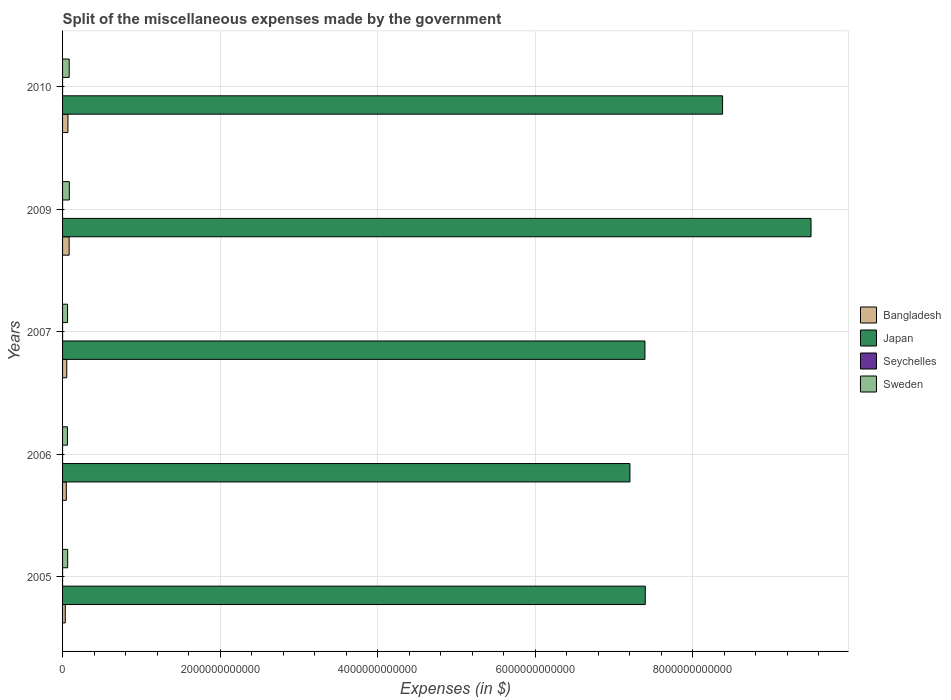How many groups of bars are there?
Offer a terse response. 5. Are the number of bars per tick equal to the number of legend labels?
Keep it short and to the point. Yes. Are the number of bars on each tick of the Y-axis equal?
Provide a succinct answer. Yes. How many bars are there on the 5th tick from the top?
Give a very brief answer. 4. What is the miscellaneous expenses made by the government in Sweden in 2006?
Your response must be concise. 6.17e+1. Across all years, what is the maximum miscellaneous expenses made by the government in Bangladesh?
Keep it short and to the point. 8.35e+1. Across all years, what is the minimum miscellaneous expenses made by the government in Sweden?
Make the answer very short. 6.17e+1. In which year was the miscellaneous expenses made by the government in Japan maximum?
Keep it short and to the point. 2009. In which year was the miscellaneous expenses made by the government in Seychelles minimum?
Ensure brevity in your answer.  2006. What is the total miscellaneous expenses made by the government in Bangladesh in the graph?
Your answer should be compact. 2.87e+11. What is the difference between the miscellaneous expenses made by the government in Bangladesh in 2007 and that in 2009?
Keep it short and to the point. -3.04e+1. What is the difference between the miscellaneous expenses made by the government in Seychelles in 2005 and the miscellaneous expenses made by the government in Bangladesh in 2007?
Your answer should be compact. -5.31e+1. What is the average miscellaneous expenses made by the government in Japan per year?
Offer a very short reply. 7.97e+12. In the year 2007, what is the difference between the miscellaneous expenses made by the government in Japan and miscellaneous expenses made by the government in Seychelles?
Your answer should be compact. 7.39e+12. What is the ratio of the miscellaneous expenses made by the government in Seychelles in 2005 to that in 2006?
Provide a succinct answer. 15.81. Is the miscellaneous expenses made by the government in Sweden in 2006 less than that in 2009?
Offer a terse response. Yes. What is the difference between the highest and the second highest miscellaneous expenses made by the government in Sweden?
Ensure brevity in your answer.  1.77e+09. What is the difference between the highest and the lowest miscellaneous expenses made by the government in Bangladesh?
Provide a short and direct response. 4.92e+1. In how many years, is the miscellaneous expenses made by the government in Sweden greater than the average miscellaneous expenses made by the government in Sweden taken over all years?
Provide a short and direct response. 2. Is it the case that in every year, the sum of the miscellaneous expenses made by the government in Japan and miscellaneous expenses made by the government in Seychelles is greater than the sum of miscellaneous expenses made by the government in Bangladesh and miscellaneous expenses made by the government in Sweden?
Ensure brevity in your answer.  Yes. What does the 2nd bar from the top in 2009 represents?
Your response must be concise. Seychelles. What does the 4th bar from the bottom in 2009 represents?
Your response must be concise. Sweden. Is it the case that in every year, the sum of the miscellaneous expenses made by the government in Bangladesh and miscellaneous expenses made by the government in Japan is greater than the miscellaneous expenses made by the government in Sweden?
Your response must be concise. Yes. How many bars are there?
Your response must be concise. 20. Are all the bars in the graph horizontal?
Your response must be concise. Yes. How many years are there in the graph?
Provide a short and direct response. 5. What is the difference between two consecutive major ticks on the X-axis?
Your answer should be compact. 2.00e+12. Does the graph contain any zero values?
Ensure brevity in your answer.  No. Where does the legend appear in the graph?
Provide a succinct answer. Center right. How many legend labels are there?
Keep it short and to the point. 4. How are the legend labels stacked?
Offer a very short reply. Vertical. What is the title of the graph?
Offer a terse response. Split of the miscellaneous expenses made by the government. Does "Armenia" appear as one of the legend labels in the graph?
Offer a very short reply. No. What is the label or title of the X-axis?
Give a very brief answer. Expenses (in $). What is the Expenses (in $) in Bangladesh in 2005?
Your answer should be compact. 3.43e+1. What is the Expenses (in $) of Japan in 2005?
Ensure brevity in your answer.  7.40e+12. What is the Expenses (in $) of Seychelles in 2005?
Provide a short and direct response. 1.26e+07. What is the Expenses (in $) of Sweden in 2005?
Give a very brief answer. 6.48e+1. What is the Expenses (in $) in Bangladesh in 2006?
Offer a very short reply. 4.73e+1. What is the Expenses (in $) of Japan in 2006?
Offer a terse response. 7.20e+12. What is the Expenses (in $) in Seychelles in 2006?
Provide a succinct answer. 8.00e+05. What is the Expenses (in $) of Sweden in 2006?
Your answer should be compact. 6.17e+1. What is the Expenses (in $) in Bangladesh in 2007?
Offer a very short reply. 5.31e+1. What is the Expenses (in $) in Japan in 2007?
Provide a succinct answer. 7.39e+12. What is the Expenses (in $) of Seychelles in 2007?
Your response must be concise. 7.22e+06. What is the Expenses (in $) in Sweden in 2007?
Keep it short and to the point. 6.32e+1. What is the Expenses (in $) of Bangladesh in 2009?
Keep it short and to the point. 8.35e+1. What is the Expenses (in $) of Japan in 2009?
Offer a terse response. 9.50e+12. What is the Expenses (in $) in Seychelles in 2009?
Give a very brief answer. 2.10e+06. What is the Expenses (in $) in Sweden in 2009?
Your answer should be compact. 8.61e+1. What is the Expenses (in $) of Bangladesh in 2010?
Give a very brief answer. 6.82e+1. What is the Expenses (in $) in Japan in 2010?
Provide a short and direct response. 8.38e+12. What is the Expenses (in $) of Seychelles in 2010?
Your response must be concise. 2.02e+06. What is the Expenses (in $) in Sweden in 2010?
Make the answer very short. 8.43e+1. Across all years, what is the maximum Expenses (in $) of Bangladesh?
Your answer should be compact. 8.35e+1. Across all years, what is the maximum Expenses (in $) of Japan?
Your response must be concise. 9.50e+12. Across all years, what is the maximum Expenses (in $) of Seychelles?
Your answer should be compact. 1.26e+07. Across all years, what is the maximum Expenses (in $) in Sweden?
Provide a succinct answer. 8.61e+1. Across all years, what is the minimum Expenses (in $) in Bangladesh?
Your answer should be compact. 3.43e+1. Across all years, what is the minimum Expenses (in $) of Japan?
Give a very brief answer. 7.20e+12. Across all years, what is the minimum Expenses (in $) of Sweden?
Your response must be concise. 6.17e+1. What is the total Expenses (in $) in Bangladesh in the graph?
Provide a succinct answer. 2.87e+11. What is the total Expenses (in $) in Japan in the graph?
Ensure brevity in your answer.  3.99e+13. What is the total Expenses (in $) in Seychelles in the graph?
Provide a succinct answer. 2.48e+07. What is the total Expenses (in $) in Sweden in the graph?
Ensure brevity in your answer.  3.60e+11. What is the difference between the Expenses (in $) of Bangladesh in 2005 and that in 2006?
Your response must be concise. -1.30e+1. What is the difference between the Expenses (in $) in Japan in 2005 and that in 2006?
Ensure brevity in your answer.  1.95e+11. What is the difference between the Expenses (in $) of Seychelles in 2005 and that in 2006?
Give a very brief answer. 1.18e+07. What is the difference between the Expenses (in $) of Sweden in 2005 and that in 2006?
Give a very brief answer. 3.06e+09. What is the difference between the Expenses (in $) of Bangladesh in 2005 and that in 2007?
Keep it short and to the point. -1.88e+1. What is the difference between the Expenses (in $) of Japan in 2005 and that in 2007?
Provide a succinct answer. 4.50e+09. What is the difference between the Expenses (in $) in Seychelles in 2005 and that in 2007?
Provide a short and direct response. 5.43e+06. What is the difference between the Expenses (in $) of Sweden in 2005 and that in 2007?
Offer a terse response. 1.60e+09. What is the difference between the Expenses (in $) in Bangladesh in 2005 and that in 2009?
Keep it short and to the point. -4.92e+1. What is the difference between the Expenses (in $) in Japan in 2005 and that in 2009?
Ensure brevity in your answer.  -2.10e+12. What is the difference between the Expenses (in $) in Seychelles in 2005 and that in 2009?
Keep it short and to the point. 1.06e+07. What is the difference between the Expenses (in $) of Sweden in 2005 and that in 2009?
Ensure brevity in your answer.  -2.13e+1. What is the difference between the Expenses (in $) of Bangladesh in 2005 and that in 2010?
Your answer should be compact. -3.39e+1. What is the difference between the Expenses (in $) of Japan in 2005 and that in 2010?
Your response must be concise. -9.81e+11. What is the difference between the Expenses (in $) of Seychelles in 2005 and that in 2010?
Make the answer very short. 1.06e+07. What is the difference between the Expenses (in $) of Sweden in 2005 and that in 2010?
Make the answer very short. -1.95e+1. What is the difference between the Expenses (in $) in Bangladesh in 2006 and that in 2007?
Provide a succinct answer. -5.81e+09. What is the difference between the Expenses (in $) in Japan in 2006 and that in 2007?
Offer a very short reply. -1.90e+11. What is the difference between the Expenses (in $) in Seychelles in 2006 and that in 2007?
Ensure brevity in your answer.  -6.42e+06. What is the difference between the Expenses (in $) in Sweden in 2006 and that in 2007?
Offer a very short reply. -1.47e+09. What is the difference between the Expenses (in $) of Bangladesh in 2006 and that in 2009?
Offer a terse response. -3.62e+1. What is the difference between the Expenses (in $) of Japan in 2006 and that in 2009?
Your answer should be compact. -2.30e+12. What is the difference between the Expenses (in $) of Seychelles in 2006 and that in 2009?
Give a very brief answer. -1.30e+06. What is the difference between the Expenses (in $) of Sweden in 2006 and that in 2009?
Offer a very short reply. -2.43e+1. What is the difference between the Expenses (in $) in Bangladesh in 2006 and that in 2010?
Offer a terse response. -2.09e+1. What is the difference between the Expenses (in $) in Japan in 2006 and that in 2010?
Offer a very short reply. -1.18e+12. What is the difference between the Expenses (in $) in Seychelles in 2006 and that in 2010?
Keep it short and to the point. -1.22e+06. What is the difference between the Expenses (in $) of Sweden in 2006 and that in 2010?
Make the answer very short. -2.26e+1. What is the difference between the Expenses (in $) in Bangladesh in 2007 and that in 2009?
Provide a succinct answer. -3.04e+1. What is the difference between the Expenses (in $) in Japan in 2007 and that in 2009?
Your answer should be very brief. -2.11e+12. What is the difference between the Expenses (in $) in Seychelles in 2007 and that in 2009?
Offer a terse response. 5.12e+06. What is the difference between the Expenses (in $) of Sweden in 2007 and that in 2009?
Offer a terse response. -2.29e+1. What is the difference between the Expenses (in $) in Bangladesh in 2007 and that in 2010?
Offer a terse response. -1.51e+1. What is the difference between the Expenses (in $) in Japan in 2007 and that in 2010?
Provide a short and direct response. -9.86e+11. What is the difference between the Expenses (in $) in Seychelles in 2007 and that in 2010?
Offer a terse response. 5.20e+06. What is the difference between the Expenses (in $) in Sweden in 2007 and that in 2010?
Keep it short and to the point. -2.11e+1. What is the difference between the Expenses (in $) in Bangladesh in 2009 and that in 2010?
Make the answer very short. 1.53e+1. What is the difference between the Expenses (in $) of Japan in 2009 and that in 2010?
Offer a terse response. 1.12e+12. What is the difference between the Expenses (in $) in Seychelles in 2009 and that in 2010?
Offer a terse response. 7.75e+04. What is the difference between the Expenses (in $) of Sweden in 2009 and that in 2010?
Offer a terse response. 1.77e+09. What is the difference between the Expenses (in $) of Bangladesh in 2005 and the Expenses (in $) of Japan in 2006?
Your answer should be compact. -7.17e+12. What is the difference between the Expenses (in $) in Bangladesh in 2005 and the Expenses (in $) in Seychelles in 2006?
Give a very brief answer. 3.43e+1. What is the difference between the Expenses (in $) of Bangladesh in 2005 and the Expenses (in $) of Sweden in 2006?
Offer a terse response. -2.74e+1. What is the difference between the Expenses (in $) of Japan in 2005 and the Expenses (in $) of Seychelles in 2006?
Your answer should be very brief. 7.40e+12. What is the difference between the Expenses (in $) of Japan in 2005 and the Expenses (in $) of Sweden in 2006?
Your answer should be compact. 7.33e+12. What is the difference between the Expenses (in $) of Seychelles in 2005 and the Expenses (in $) of Sweden in 2006?
Provide a short and direct response. -6.17e+1. What is the difference between the Expenses (in $) of Bangladesh in 2005 and the Expenses (in $) of Japan in 2007?
Provide a short and direct response. -7.36e+12. What is the difference between the Expenses (in $) of Bangladesh in 2005 and the Expenses (in $) of Seychelles in 2007?
Provide a succinct answer. 3.43e+1. What is the difference between the Expenses (in $) of Bangladesh in 2005 and the Expenses (in $) of Sweden in 2007?
Offer a terse response. -2.89e+1. What is the difference between the Expenses (in $) in Japan in 2005 and the Expenses (in $) in Seychelles in 2007?
Make the answer very short. 7.40e+12. What is the difference between the Expenses (in $) in Japan in 2005 and the Expenses (in $) in Sweden in 2007?
Provide a short and direct response. 7.33e+12. What is the difference between the Expenses (in $) of Seychelles in 2005 and the Expenses (in $) of Sweden in 2007?
Your answer should be very brief. -6.32e+1. What is the difference between the Expenses (in $) in Bangladesh in 2005 and the Expenses (in $) in Japan in 2009?
Offer a very short reply. -9.47e+12. What is the difference between the Expenses (in $) of Bangladesh in 2005 and the Expenses (in $) of Seychelles in 2009?
Offer a very short reply. 3.43e+1. What is the difference between the Expenses (in $) in Bangladesh in 2005 and the Expenses (in $) in Sweden in 2009?
Offer a terse response. -5.17e+1. What is the difference between the Expenses (in $) of Japan in 2005 and the Expenses (in $) of Seychelles in 2009?
Provide a short and direct response. 7.40e+12. What is the difference between the Expenses (in $) in Japan in 2005 and the Expenses (in $) in Sweden in 2009?
Ensure brevity in your answer.  7.31e+12. What is the difference between the Expenses (in $) of Seychelles in 2005 and the Expenses (in $) of Sweden in 2009?
Provide a short and direct response. -8.61e+1. What is the difference between the Expenses (in $) of Bangladesh in 2005 and the Expenses (in $) of Japan in 2010?
Provide a succinct answer. -8.34e+12. What is the difference between the Expenses (in $) of Bangladesh in 2005 and the Expenses (in $) of Seychelles in 2010?
Your response must be concise. 3.43e+1. What is the difference between the Expenses (in $) of Bangladesh in 2005 and the Expenses (in $) of Sweden in 2010?
Your response must be concise. -5.00e+1. What is the difference between the Expenses (in $) of Japan in 2005 and the Expenses (in $) of Seychelles in 2010?
Give a very brief answer. 7.40e+12. What is the difference between the Expenses (in $) of Japan in 2005 and the Expenses (in $) of Sweden in 2010?
Your answer should be compact. 7.31e+12. What is the difference between the Expenses (in $) in Seychelles in 2005 and the Expenses (in $) in Sweden in 2010?
Provide a succinct answer. -8.43e+1. What is the difference between the Expenses (in $) in Bangladesh in 2006 and the Expenses (in $) in Japan in 2007?
Your answer should be very brief. -7.34e+12. What is the difference between the Expenses (in $) in Bangladesh in 2006 and the Expenses (in $) in Seychelles in 2007?
Make the answer very short. 4.73e+1. What is the difference between the Expenses (in $) of Bangladesh in 2006 and the Expenses (in $) of Sweden in 2007?
Keep it short and to the point. -1.59e+1. What is the difference between the Expenses (in $) of Japan in 2006 and the Expenses (in $) of Seychelles in 2007?
Provide a succinct answer. 7.20e+12. What is the difference between the Expenses (in $) in Japan in 2006 and the Expenses (in $) in Sweden in 2007?
Your answer should be very brief. 7.14e+12. What is the difference between the Expenses (in $) in Seychelles in 2006 and the Expenses (in $) in Sweden in 2007?
Make the answer very short. -6.32e+1. What is the difference between the Expenses (in $) of Bangladesh in 2006 and the Expenses (in $) of Japan in 2009?
Give a very brief answer. -9.45e+12. What is the difference between the Expenses (in $) in Bangladesh in 2006 and the Expenses (in $) in Seychelles in 2009?
Make the answer very short. 4.73e+1. What is the difference between the Expenses (in $) in Bangladesh in 2006 and the Expenses (in $) in Sweden in 2009?
Ensure brevity in your answer.  -3.87e+1. What is the difference between the Expenses (in $) of Japan in 2006 and the Expenses (in $) of Seychelles in 2009?
Offer a very short reply. 7.20e+12. What is the difference between the Expenses (in $) of Japan in 2006 and the Expenses (in $) of Sweden in 2009?
Make the answer very short. 7.12e+12. What is the difference between the Expenses (in $) in Seychelles in 2006 and the Expenses (in $) in Sweden in 2009?
Offer a terse response. -8.61e+1. What is the difference between the Expenses (in $) in Bangladesh in 2006 and the Expenses (in $) in Japan in 2010?
Offer a very short reply. -8.33e+12. What is the difference between the Expenses (in $) in Bangladesh in 2006 and the Expenses (in $) in Seychelles in 2010?
Provide a succinct answer. 4.73e+1. What is the difference between the Expenses (in $) of Bangladesh in 2006 and the Expenses (in $) of Sweden in 2010?
Keep it short and to the point. -3.70e+1. What is the difference between the Expenses (in $) of Japan in 2006 and the Expenses (in $) of Seychelles in 2010?
Provide a succinct answer. 7.20e+12. What is the difference between the Expenses (in $) of Japan in 2006 and the Expenses (in $) of Sweden in 2010?
Offer a terse response. 7.12e+12. What is the difference between the Expenses (in $) in Seychelles in 2006 and the Expenses (in $) in Sweden in 2010?
Give a very brief answer. -8.43e+1. What is the difference between the Expenses (in $) in Bangladesh in 2007 and the Expenses (in $) in Japan in 2009?
Offer a terse response. -9.45e+12. What is the difference between the Expenses (in $) of Bangladesh in 2007 and the Expenses (in $) of Seychelles in 2009?
Provide a succinct answer. 5.31e+1. What is the difference between the Expenses (in $) in Bangladesh in 2007 and the Expenses (in $) in Sweden in 2009?
Your answer should be very brief. -3.29e+1. What is the difference between the Expenses (in $) in Japan in 2007 and the Expenses (in $) in Seychelles in 2009?
Your response must be concise. 7.39e+12. What is the difference between the Expenses (in $) of Japan in 2007 and the Expenses (in $) of Sweden in 2009?
Provide a succinct answer. 7.31e+12. What is the difference between the Expenses (in $) of Seychelles in 2007 and the Expenses (in $) of Sweden in 2009?
Your answer should be compact. -8.61e+1. What is the difference between the Expenses (in $) in Bangladesh in 2007 and the Expenses (in $) in Japan in 2010?
Your answer should be very brief. -8.32e+12. What is the difference between the Expenses (in $) in Bangladesh in 2007 and the Expenses (in $) in Seychelles in 2010?
Your answer should be very brief. 5.31e+1. What is the difference between the Expenses (in $) in Bangladesh in 2007 and the Expenses (in $) in Sweden in 2010?
Keep it short and to the point. -3.12e+1. What is the difference between the Expenses (in $) of Japan in 2007 and the Expenses (in $) of Seychelles in 2010?
Offer a very short reply. 7.39e+12. What is the difference between the Expenses (in $) of Japan in 2007 and the Expenses (in $) of Sweden in 2010?
Keep it short and to the point. 7.31e+12. What is the difference between the Expenses (in $) of Seychelles in 2007 and the Expenses (in $) of Sweden in 2010?
Your answer should be very brief. -8.43e+1. What is the difference between the Expenses (in $) in Bangladesh in 2009 and the Expenses (in $) in Japan in 2010?
Your response must be concise. -8.29e+12. What is the difference between the Expenses (in $) in Bangladesh in 2009 and the Expenses (in $) in Seychelles in 2010?
Give a very brief answer. 8.35e+1. What is the difference between the Expenses (in $) in Bangladesh in 2009 and the Expenses (in $) in Sweden in 2010?
Your answer should be compact. -7.54e+08. What is the difference between the Expenses (in $) of Japan in 2009 and the Expenses (in $) of Seychelles in 2010?
Make the answer very short. 9.50e+12. What is the difference between the Expenses (in $) of Japan in 2009 and the Expenses (in $) of Sweden in 2010?
Provide a short and direct response. 9.42e+12. What is the difference between the Expenses (in $) of Seychelles in 2009 and the Expenses (in $) of Sweden in 2010?
Offer a very short reply. -8.43e+1. What is the average Expenses (in $) in Bangladesh per year?
Give a very brief answer. 5.73e+1. What is the average Expenses (in $) in Japan per year?
Give a very brief answer. 7.97e+12. What is the average Expenses (in $) of Seychelles per year?
Offer a terse response. 4.96e+06. What is the average Expenses (in $) in Sweden per year?
Offer a very short reply. 7.20e+1. In the year 2005, what is the difference between the Expenses (in $) of Bangladesh and Expenses (in $) of Japan?
Your response must be concise. -7.36e+12. In the year 2005, what is the difference between the Expenses (in $) in Bangladesh and Expenses (in $) in Seychelles?
Ensure brevity in your answer.  3.43e+1. In the year 2005, what is the difference between the Expenses (in $) in Bangladesh and Expenses (in $) in Sweden?
Provide a succinct answer. -3.05e+1. In the year 2005, what is the difference between the Expenses (in $) in Japan and Expenses (in $) in Seychelles?
Provide a short and direct response. 7.40e+12. In the year 2005, what is the difference between the Expenses (in $) of Japan and Expenses (in $) of Sweden?
Make the answer very short. 7.33e+12. In the year 2005, what is the difference between the Expenses (in $) in Seychelles and Expenses (in $) in Sweden?
Your response must be concise. -6.48e+1. In the year 2006, what is the difference between the Expenses (in $) of Bangladesh and Expenses (in $) of Japan?
Make the answer very short. -7.15e+12. In the year 2006, what is the difference between the Expenses (in $) in Bangladesh and Expenses (in $) in Seychelles?
Offer a terse response. 4.73e+1. In the year 2006, what is the difference between the Expenses (in $) in Bangladesh and Expenses (in $) in Sweden?
Give a very brief answer. -1.44e+1. In the year 2006, what is the difference between the Expenses (in $) of Japan and Expenses (in $) of Seychelles?
Offer a terse response. 7.20e+12. In the year 2006, what is the difference between the Expenses (in $) in Japan and Expenses (in $) in Sweden?
Your answer should be compact. 7.14e+12. In the year 2006, what is the difference between the Expenses (in $) of Seychelles and Expenses (in $) of Sweden?
Offer a terse response. -6.17e+1. In the year 2007, what is the difference between the Expenses (in $) in Bangladesh and Expenses (in $) in Japan?
Provide a succinct answer. -7.34e+12. In the year 2007, what is the difference between the Expenses (in $) in Bangladesh and Expenses (in $) in Seychelles?
Keep it short and to the point. 5.31e+1. In the year 2007, what is the difference between the Expenses (in $) of Bangladesh and Expenses (in $) of Sweden?
Your response must be concise. -1.01e+1. In the year 2007, what is the difference between the Expenses (in $) of Japan and Expenses (in $) of Seychelles?
Provide a succinct answer. 7.39e+12. In the year 2007, what is the difference between the Expenses (in $) in Japan and Expenses (in $) in Sweden?
Make the answer very short. 7.33e+12. In the year 2007, what is the difference between the Expenses (in $) of Seychelles and Expenses (in $) of Sweden?
Make the answer very short. -6.32e+1. In the year 2009, what is the difference between the Expenses (in $) in Bangladesh and Expenses (in $) in Japan?
Your answer should be compact. -9.42e+12. In the year 2009, what is the difference between the Expenses (in $) of Bangladesh and Expenses (in $) of Seychelles?
Your answer should be compact. 8.35e+1. In the year 2009, what is the difference between the Expenses (in $) of Bangladesh and Expenses (in $) of Sweden?
Provide a short and direct response. -2.53e+09. In the year 2009, what is the difference between the Expenses (in $) in Japan and Expenses (in $) in Seychelles?
Offer a very short reply. 9.50e+12. In the year 2009, what is the difference between the Expenses (in $) of Japan and Expenses (in $) of Sweden?
Ensure brevity in your answer.  9.41e+12. In the year 2009, what is the difference between the Expenses (in $) in Seychelles and Expenses (in $) in Sweden?
Your response must be concise. -8.61e+1. In the year 2010, what is the difference between the Expenses (in $) in Bangladesh and Expenses (in $) in Japan?
Provide a short and direct response. -8.31e+12. In the year 2010, what is the difference between the Expenses (in $) in Bangladesh and Expenses (in $) in Seychelles?
Keep it short and to the point. 6.82e+1. In the year 2010, what is the difference between the Expenses (in $) of Bangladesh and Expenses (in $) of Sweden?
Ensure brevity in your answer.  -1.60e+1. In the year 2010, what is the difference between the Expenses (in $) of Japan and Expenses (in $) of Seychelles?
Provide a short and direct response. 8.38e+12. In the year 2010, what is the difference between the Expenses (in $) in Japan and Expenses (in $) in Sweden?
Offer a terse response. 8.29e+12. In the year 2010, what is the difference between the Expenses (in $) in Seychelles and Expenses (in $) in Sweden?
Provide a succinct answer. -8.43e+1. What is the ratio of the Expenses (in $) of Bangladesh in 2005 to that in 2006?
Offer a terse response. 0.73. What is the ratio of the Expenses (in $) of Japan in 2005 to that in 2006?
Offer a terse response. 1.03. What is the ratio of the Expenses (in $) of Seychelles in 2005 to that in 2006?
Give a very brief answer. 15.81. What is the ratio of the Expenses (in $) in Sweden in 2005 to that in 2006?
Provide a succinct answer. 1.05. What is the ratio of the Expenses (in $) in Bangladesh in 2005 to that in 2007?
Provide a succinct answer. 0.65. What is the ratio of the Expenses (in $) of Japan in 2005 to that in 2007?
Provide a succinct answer. 1. What is the ratio of the Expenses (in $) in Seychelles in 2005 to that in 2007?
Offer a very short reply. 1.75. What is the ratio of the Expenses (in $) of Sweden in 2005 to that in 2007?
Your response must be concise. 1.03. What is the ratio of the Expenses (in $) of Bangladesh in 2005 to that in 2009?
Give a very brief answer. 0.41. What is the ratio of the Expenses (in $) of Japan in 2005 to that in 2009?
Provide a succinct answer. 0.78. What is the ratio of the Expenses (in $) of Seychelles in 2005 to that in 2009?
Your response must be concise. 6.02. What is the ratio of the Expenses (in $) in Sweden in 2005 to that in 2009?
Offer a very short reply. 0.75. What is the ratio of the Expenses (in $) of Bangladesh in 2005 to that in 2010?
Give a very brief answer. 0.5. What is the ratio of the Expenses (in $) of Japan in 2005 to that in 2010?
Provide a succinct answer. 0.88. What is the ratio of the Expenses (in $) of Seychelles in 2005 to that in 2010?
Offer a terse response. 6.25. What is the ratio of the Expenses (in $) of Sweden in 2005 to that in 2010?
Keep it short and to the point. 0.77. What is the ratio of the Expenses (in $) of Bangladesh in 2006 to that in 2007?
Provide a short and direct response. 0.89. What is the ratio of the Expenses (in $) of Japan in 2006 to that in 2007?
Provide a succinct answer. 0.97. What is the ratio of the Expenses (in $) of Seychelles in 2006 to that in 2007?
Offer a very short reply. 0.11. What is the ratio of the Expenses (in $) of Sweden in 2006 to that in 2007?
Ensure brevity in your answer.  0.98. What is the ratio of the Expenses (in $) of Bangladesh in 2006 to that in 2009?
Ensure brevity in your answer.  0.57. What is the ratio of the Expenses (in $) in Japan in 2006 to that in 2009?
Offer a terse response. 0.76. What is the ratio of the Expenses (in $) in Seychelles in 2006 to that in 2009?
Ensure brevity in your answer.  0.38. What is the ratio of the Expenses (in $) of Sweden in 2006 to that in 2009?
Offer a very short reply. 0.72. What is the ratio of the Expenses (in $) in Bangladesh in 2006 to that in 2010?
Offer a very short reply. 0.69. What is the ratio of the Expenses (in $) in Japan in 2006 to that in 2010?
Keep it short and to the point. 0.86. What is the ratio of the Expenses (in $) of Seychelles in 2006 to that in 2010?
Provide a succinct answer. 0.4. What is the ratio of the Expenses (in $) in Sweden in 2006 to that in 2010?
Your answer should be compact. 0.73. What is the ratio of the Expenses (in $) of Bangladesh in 2007 to that in 2009?
Provide a succinct answer. 0.64. What is the ratio of the Expenses (in $) of Japan in 2007 to that in 2009?
Keep it short and to the point. 0.78. What is the ratio of the Expenses (in $) of Seychelles in 2007 to that in 2009?
Your answer should be very brief. 3.44. What is the ratio of the Expenses (in $) of Sweden in 2007 to that in 2009?
Make the answer very short. 0.73. What is the ratio of the Expenses (in $) in Bangladesh in 2007 to that in 2010?
Make the answer very short. 0.78. What is the ratio of the Expenses (in $) of Japan in 2007 to that in 2010?
Keep it short and to the point. 0.88. What is the ratio of the Expenses (in $) of Seychelles in 2007 to that in 2010?
Provide a short and direct response. 3.57. What is the ratio of the Expenses (in $) of Sweden in 2007 to that in 2010?
Ensure brevity in your answer.  0.75. What is the ratio of the Expenses (in $) of Bangladesh in 2009 to that in 2010?
Your answer should be very brief. 1.22. What is the ratio of the Expenses (in $) in Japan in 2009 to that in 2010?
Keep it short and to the point. 1.13. What is the ratio of the Expenses (in $) of Seychelles in 2009 to that in 2010?
Your answer should be very brief. 1.04. What is the ratio of the Expenses (in $) in Sweden in 2009 to that in 2010?
Ensure brevity in your answer.  1.02. What is the difference between the highest and the second highest Expenses (in $) of Bangladesh?
Give a very brief answer. 1.53e+1. What is the difference between the highest and the second highest Expenses (in $) in Japan?
Ensure brevity in your answer.  1.12e+12. What is the difference between the highest and the second highest Expenses (in $) of Seychelles?
Your response must be concise. 5.43e+06. What is the difference between the highest and the second highest Expenses (in $) in Sweden?
Offer a terse response. 1.77e+09. What is the difference between the highest and the lowest Expenses (in $) of Bangladesh?
Offer a terse response. 4.92e+1. What is the difference between the highest and the lowest Expenses (in $) in Japan?
Ensure brevity in your answer.  2.30e+12. What is the difference between the highest and the lowest Expenses (in $) of Seychelles?
Offer a terse response. 1.18e+07. What is the difference between the highest and the lowest Expenses (in $) of Sweden?
Ensure brevity in your answer.  2.43e+1. 